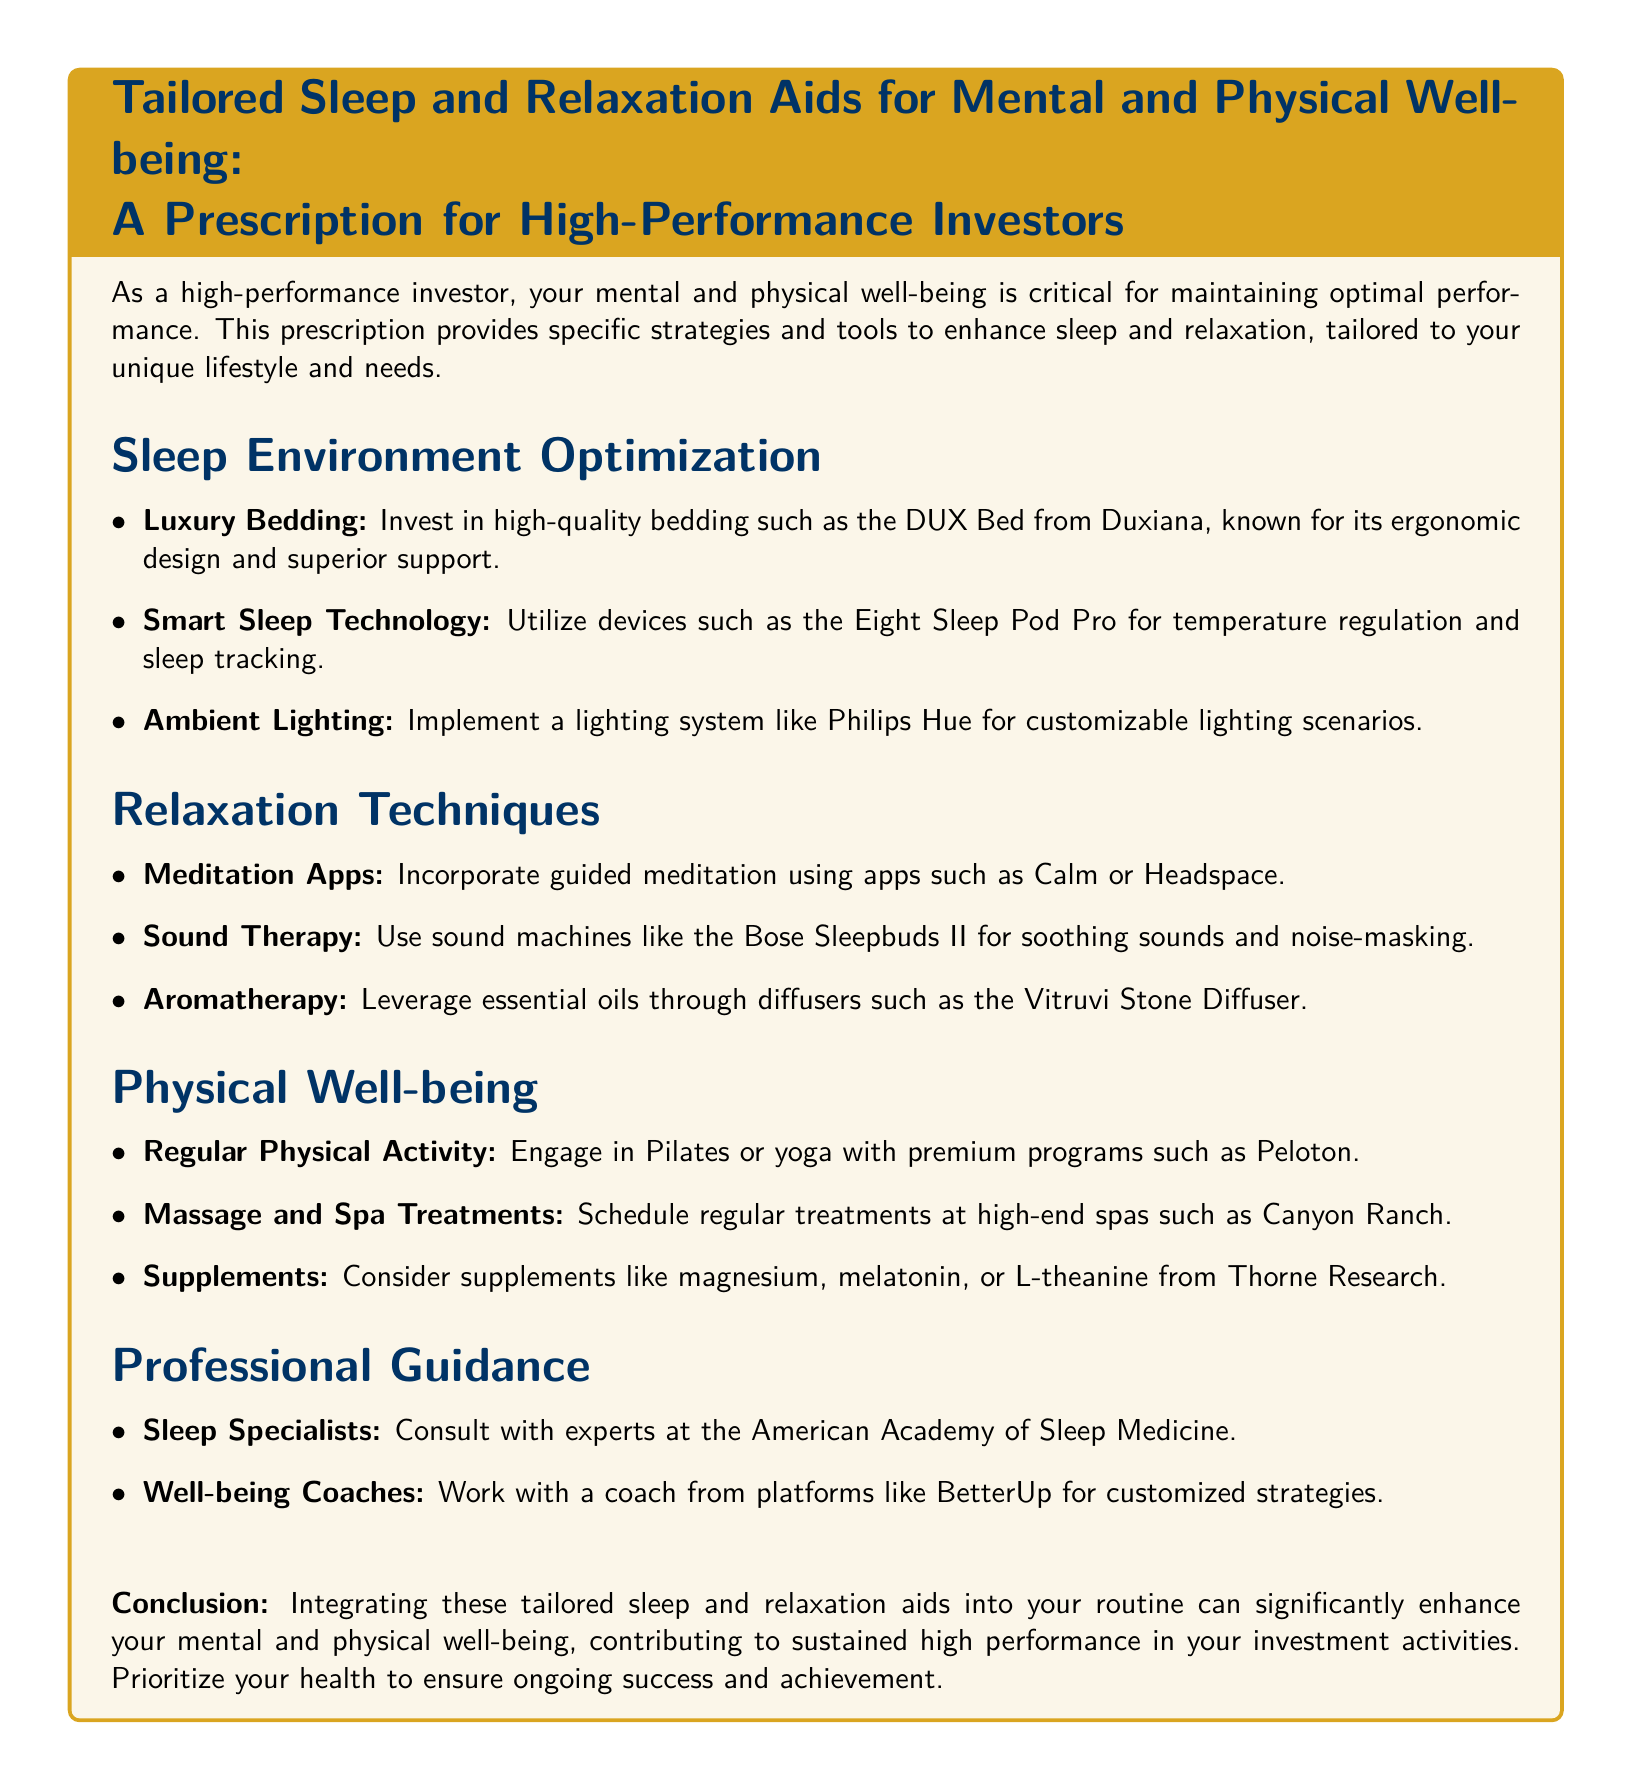What is the title of the prescription? The title clearly states the purpose of the document, which is tailored for high-performance investors focusing on sleep and relaxation aids.
Answer: Tailored Sleep and Relaxation Aids for Mental and Physical Well-being: A Prescription for High-Performance Investors What brand of bedding is recommended? The document specifies a high-quality bedding option for sleep optimization, highlighting its benefits for high-performance investors.
Answer: DUX Bed from Duxiana Which app is suggested for guided meditation? The document lists meditation apps that can help investors manage stress, explicitly naming one in the text.
Answer: Calm What type of physical activity is recommended? The document emphasizes the importance of regular physical activity for well-being, specifying a type of exercise that is beneficial.
Answer: Pilates or yoga Which spa is mentioned for treatments? The document suggests a specific high-end spa where investors can schedule their wellness treatments.
Answer: Canyon Ranch What technology is recommended for sleep temperature regulation? The document mentions a smart device aimed at improving sleep quality through temperature control.
Answer: Eight Sleep Pod Pro How often should one engage in physical activity according to the document? The document emphasizes the importance of physical activity as part of overall well-being, mentioning the necessity of regular involvement.
Answer: Regular What organization can provide professional sleep guidance? The document identifies a specific professional body where high-performance investors can seek expert advice on sleep issues.
Answer: American Academy of Sleep Medicine Which supplement is suggested for relaxation? The document lists specific supplements that can aid in relaxation and sleep quality tailored for high-performance individuals.
Answer: Magnesium What is the main purpose of integrating these recommendations? The document concludes with a summary of the overarching benefit of the suggested aids for high-performance investors.
Answer: Enhance mental and physical well-being 